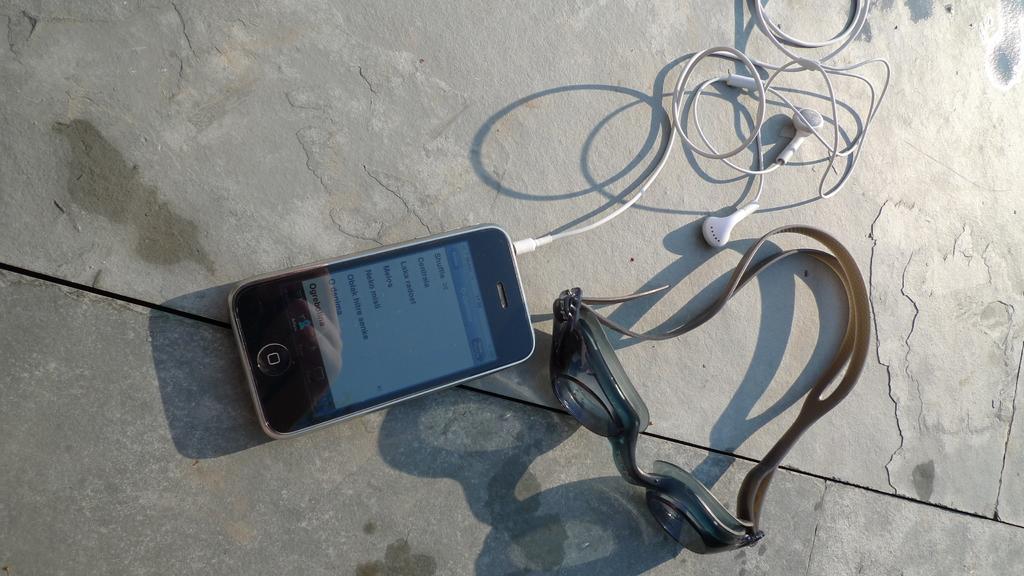What is the first option on the phone's menu?
Offer a terse response. Shuffle. 